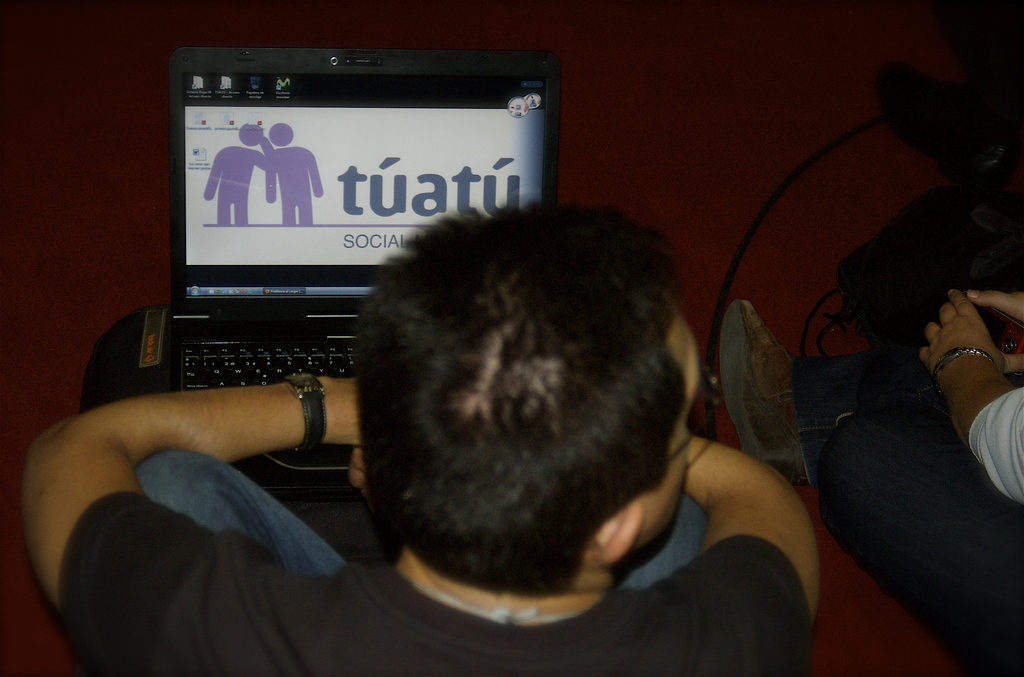Provide a one-sentence caption for the provided image.
Reference OCR token: tuatu, SOCIAL A man's laptop is open to the Tuatu website. 